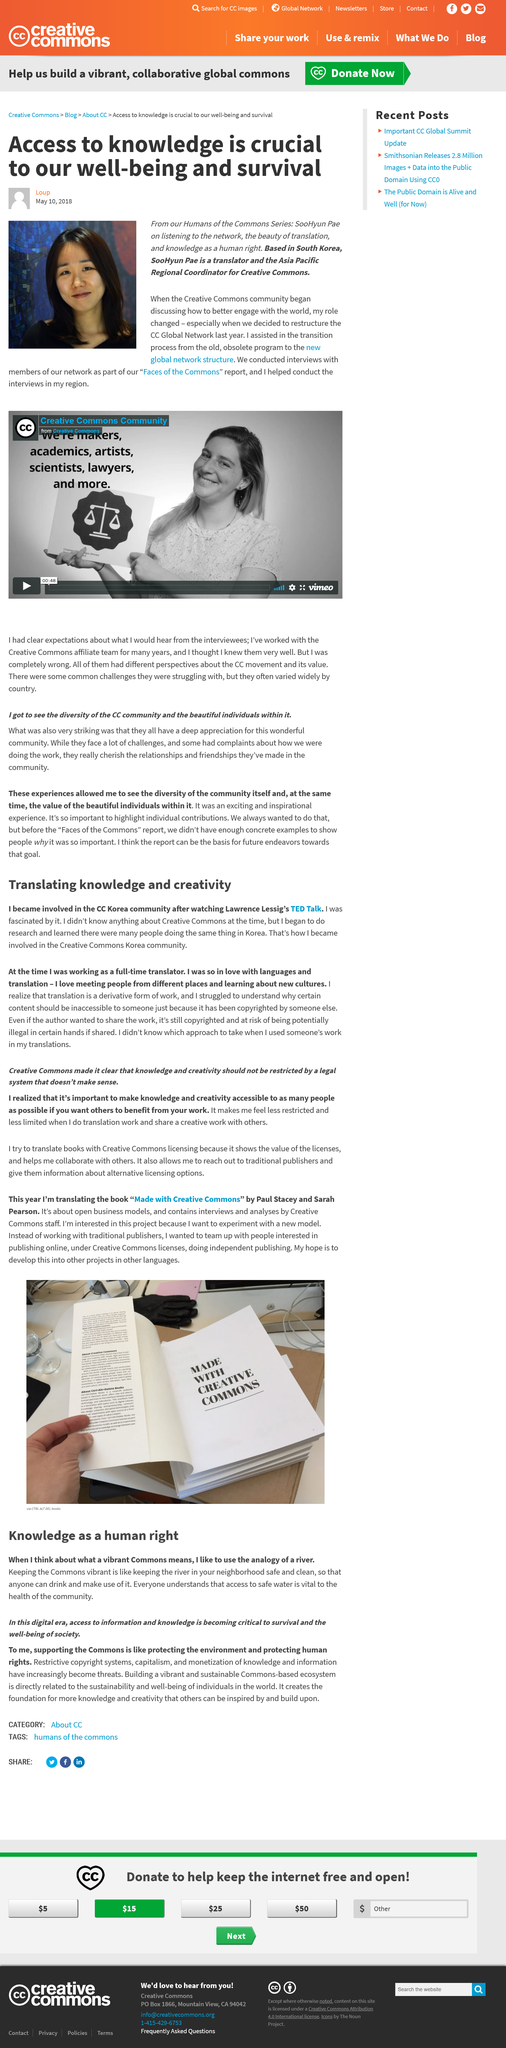Give some essential details in this illustration. The woman in the photo on the left is SooHyun Pae. The author loves meeting people from different places and learning about new cultures. CC" is an abbreviation that stands for "Creative Commons. SooHyun is a translator and Asia Pacific Regional Coordinator for Creative Commons, responsible for facilitating the translation and dissemination of Creative Commons' copyrighted material throughout the Asia Pacific region. The author of the article is Loup. 